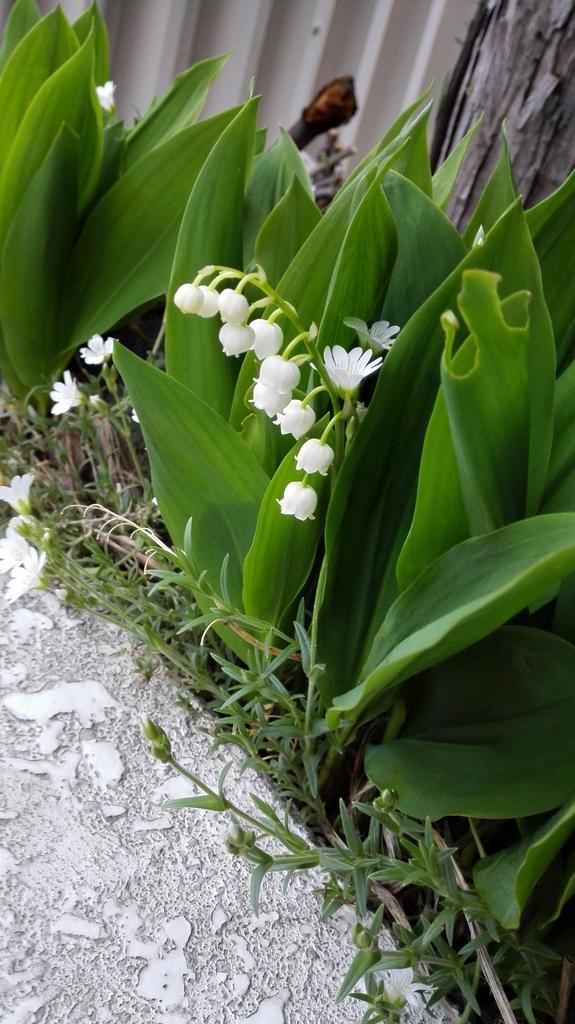Describe this image in one or two sentences. In this picture I can observe white color flowers in the middle of the picture. I can observe plants in this picture. On the left side I can observe flower petals on the land. 